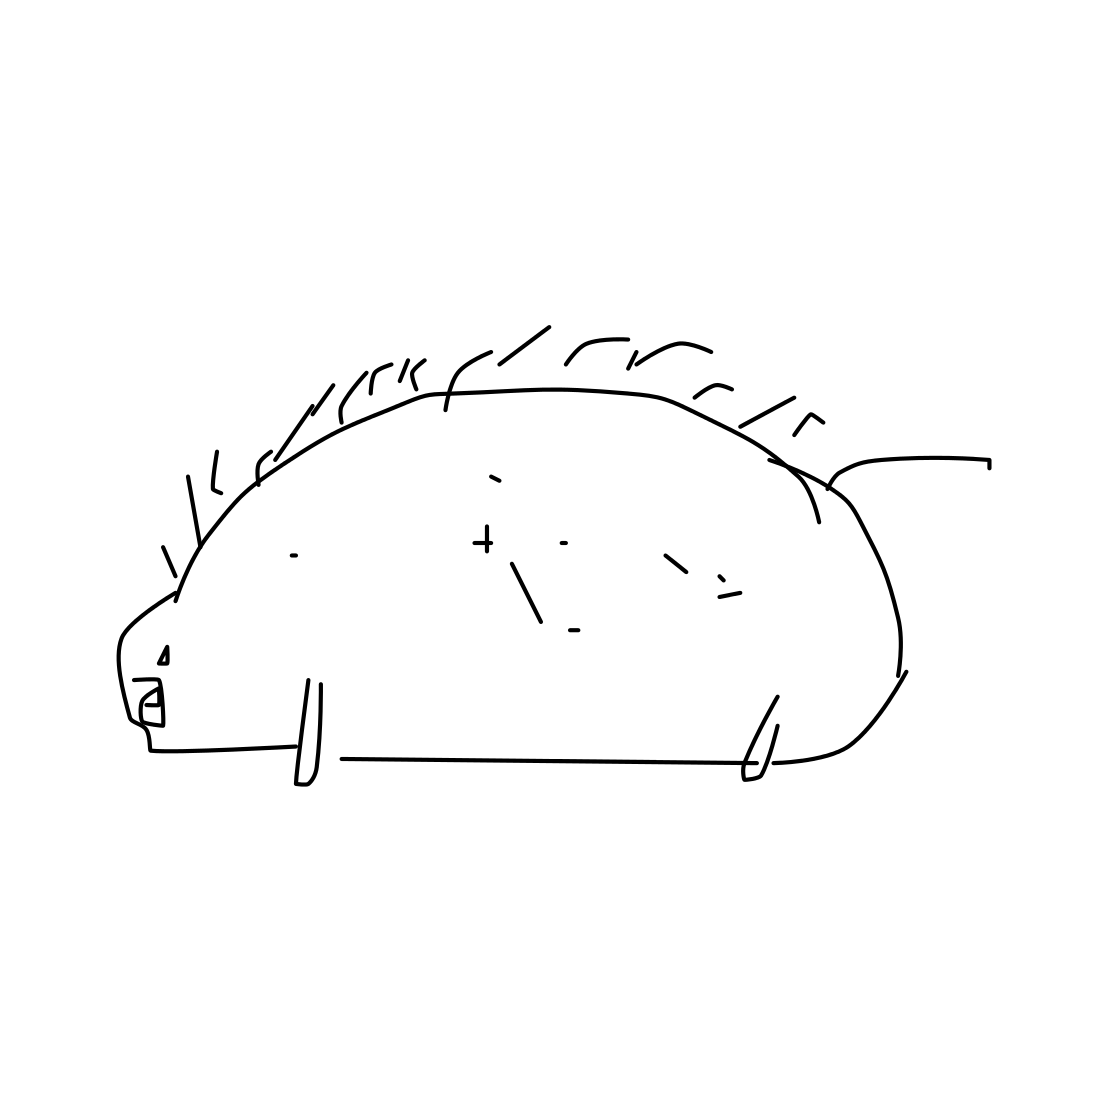What artistic style is used to create this hedgehog? The hedgehog is drawn in a minimalistic, sketch-like artistic style, utilizing simple lines and minimal detail to convey the animal's form. This style emphasizes clarity and simplicity. 